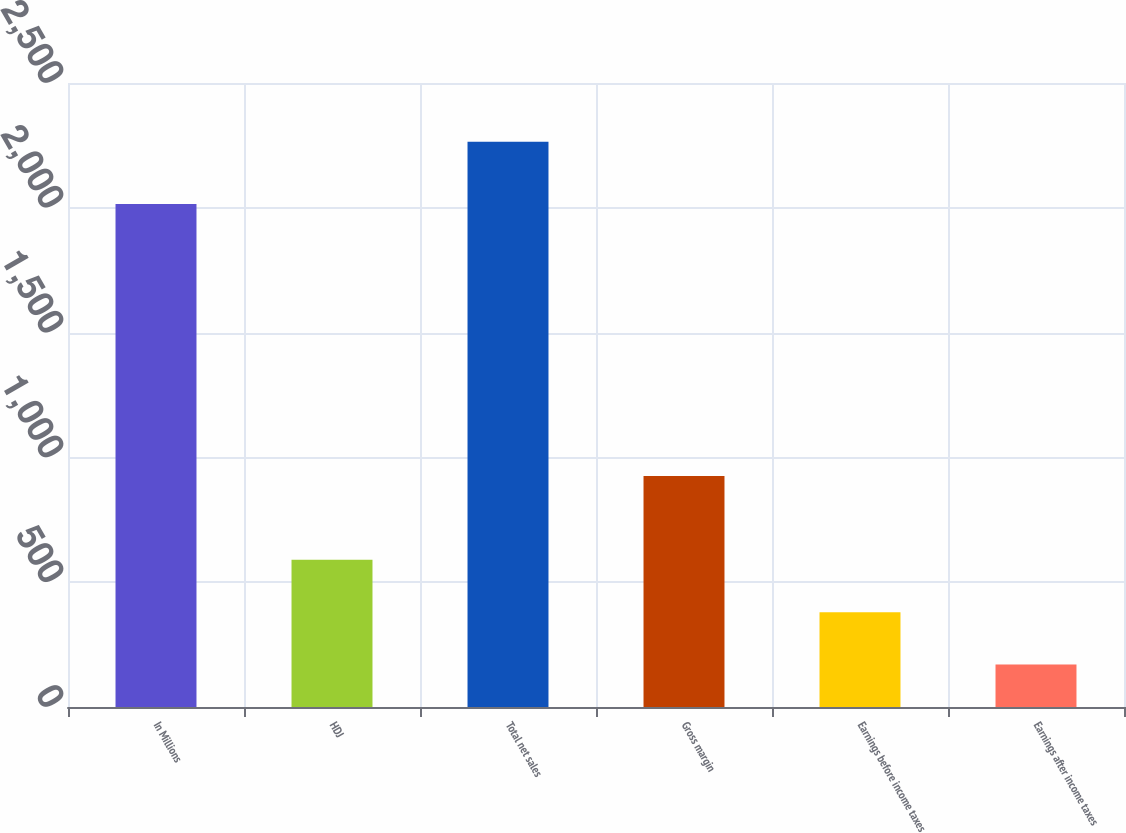<chart> <loc_0><loc_0><loc_500><loc_500><bar_chart><fcel>In Millions<fcel>HDJ<fcel>Total net sales<fcel>Gross margin<fcel>Earnings before income taxes<fcel>Earnings after income taxes<nl><fcel>2015<fcel>589.5<fcel>2264.7<fcel>925.4<fcel>380.1<fcel>170.7<nl></chart> 